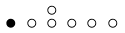Convert formula to latex. <formula><loc_0><loc_0><loc_500><loc_500>\begin{smallmatrix} & & \circ \\ \bullet & \circ & \circ & \circ & \circ & \circ & \\ \end{smallmatrix}</formula> 